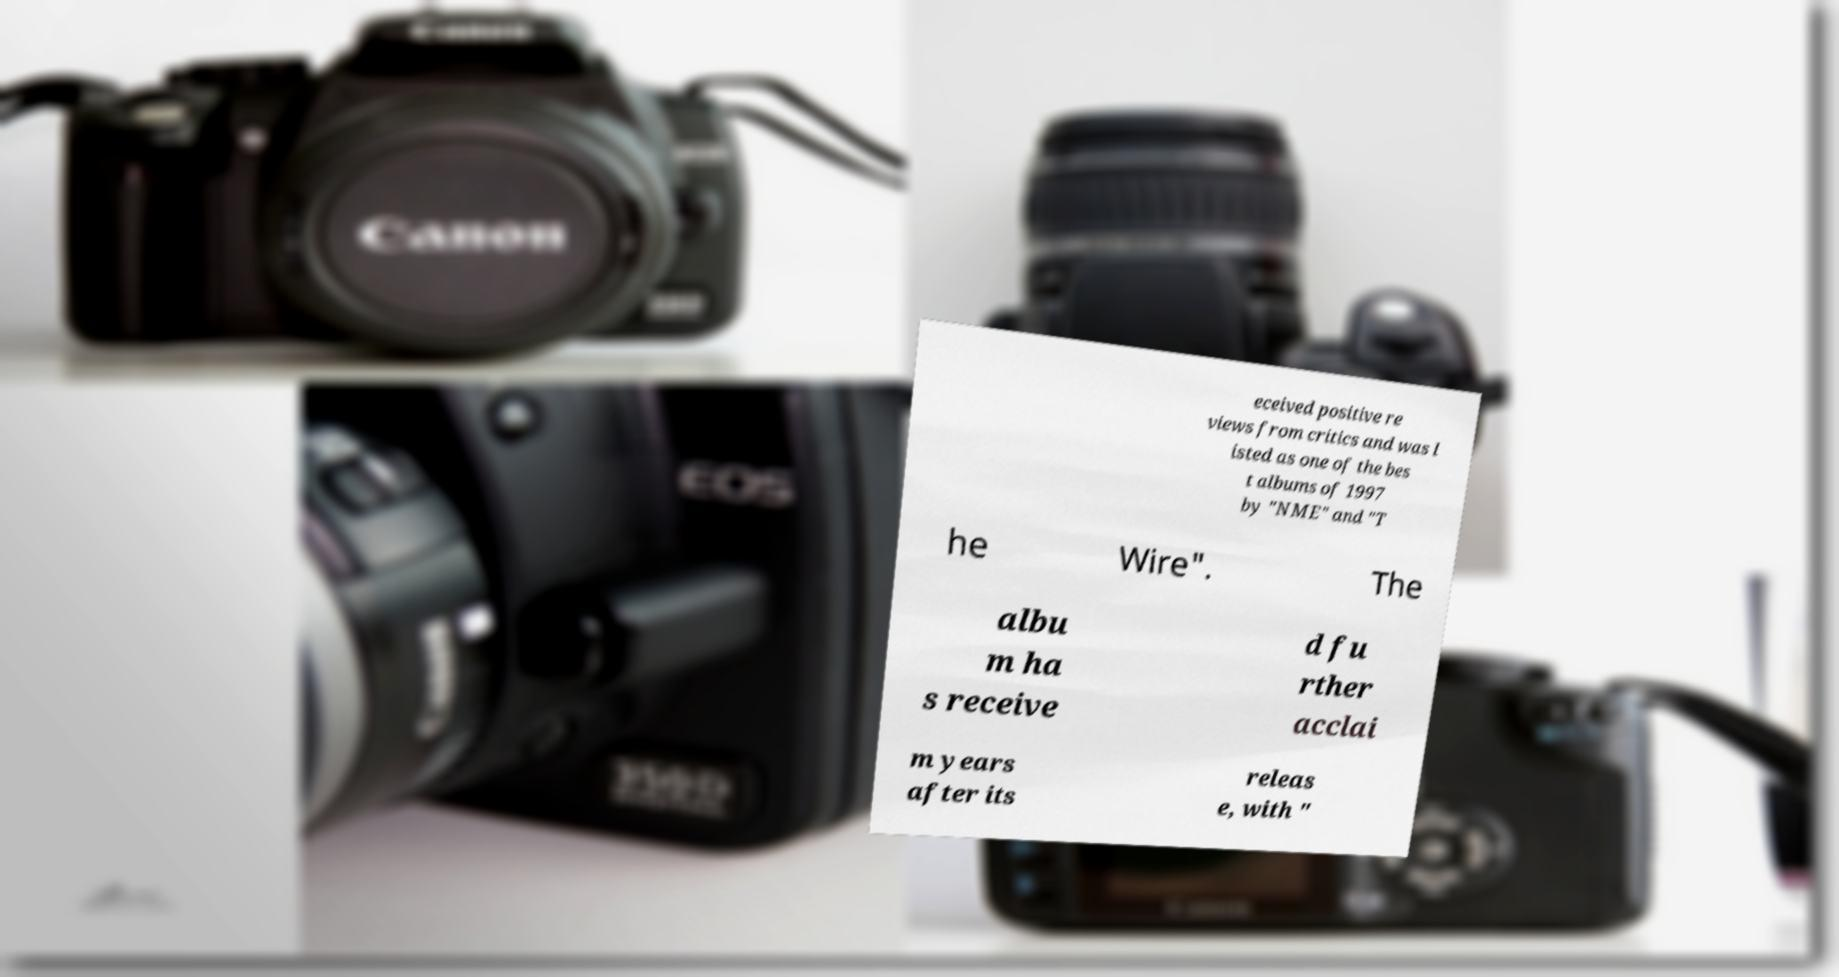Can you accurately transcribe the text from the provided image for me? eceived positive re views from critics and was l isted as one of the bes t albums of 1997 by "NME" and "T he Wire". The albu m ha s receive d fu rther acclai m years after its releas e, with " 